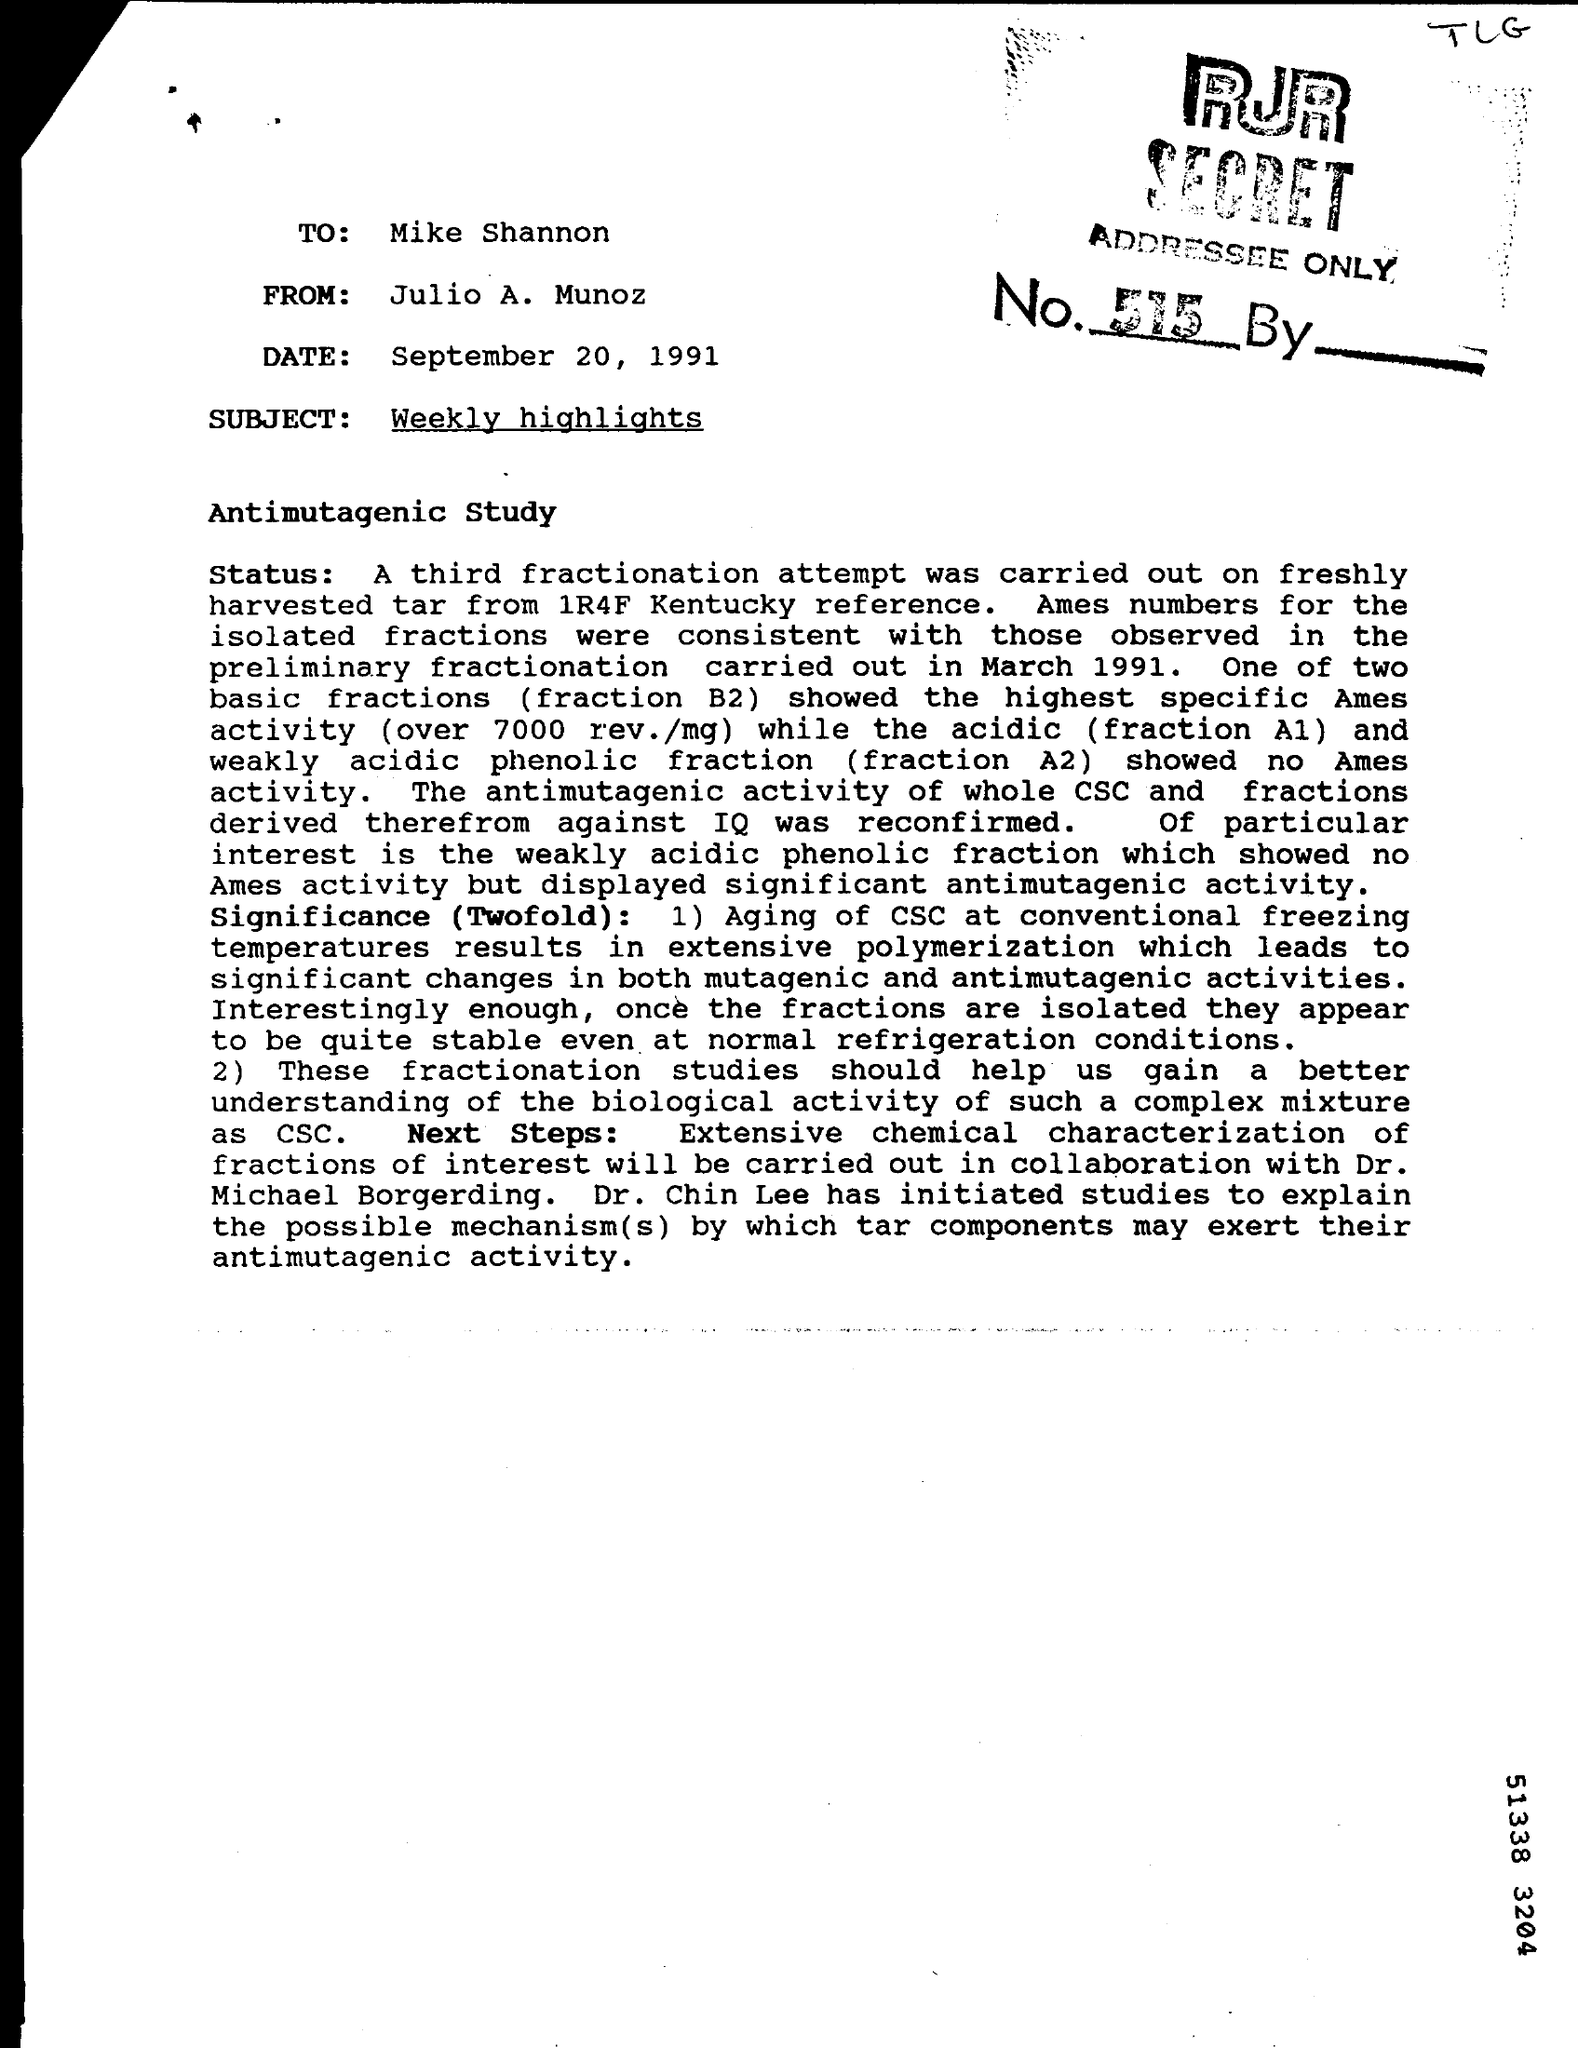To whom this letter was written ?
Keep it short and to the point. Mike shannon. Who had written this letter ?
Provide a short and direct response. Julio a. munoz. What is the date mentioned in the letter ?
Provide a succinct answer. September 20 , 1991. What is the subject mentioned in the given letter ?
Provide a succinct answer. Weekly highlights. 